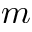<formula> <loc_0><loc_0><loc_500><loc_500>m</formula> 